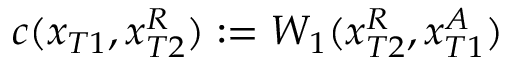Convert formula to latex. <formula><loc_0><loc_0><loc_500><loc_500>c ( x _ { T 1 } , x _ { T 2 } ^ { R } ) \colon = W _ { 1 } ( x _ { T 2 } ^ { R } , x _ { T 1 } ^ { A } )</formula> 